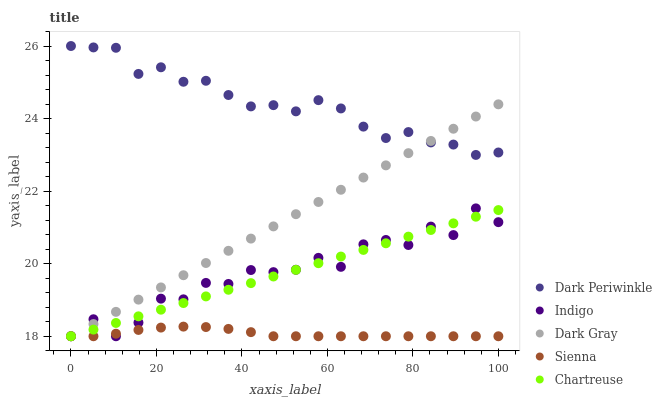Does Sienna have the minimum area under the curve?
Answer yes or no. Yes. Does Dark Periwinkle have the maximum area under the curve?
Answer yes or no. Yes. Does Chartreuse have the minimum area under the curve?
Answer yes or no. No. Does Chartreuse have the maximum area under the curve?
Answer yes or no. No. Is Dark Gray the smoothest?
Answer yes or no. Yes. Is Indigo the roughest?
Answer yes or no. Yes. Is Sienna the smoothest?
Answer yes or no. No. Is Sienna the roughest?
Answer yes or no. No. Does Dark Gray have the lowest value?
Answer yes or no. Yes. Does Dark Periwinkle have the lowest value?
Answer yes or no. No. Does Dark Periwinkle have the highest value?
Answer yes or no. Yes. Does Chartreuse have the highest value?
Answer yes or no. No. Is Indigo less than Dark Periwinkle?
Answer yes or no. Yes. Is Dark Periwinkle greater than Indigo?
Answer yes or no. Yes. Does Dark Gray intersect Sienna?
Answer yes or no. Yes. Is Dark Gray less than Sienna?
Answer yes or no. No. Is Dark Gray greater than Sienna?
Answer yes or no. No. Does Indigo intersect Dark Periwinkle?
Answer yes or no. No. 